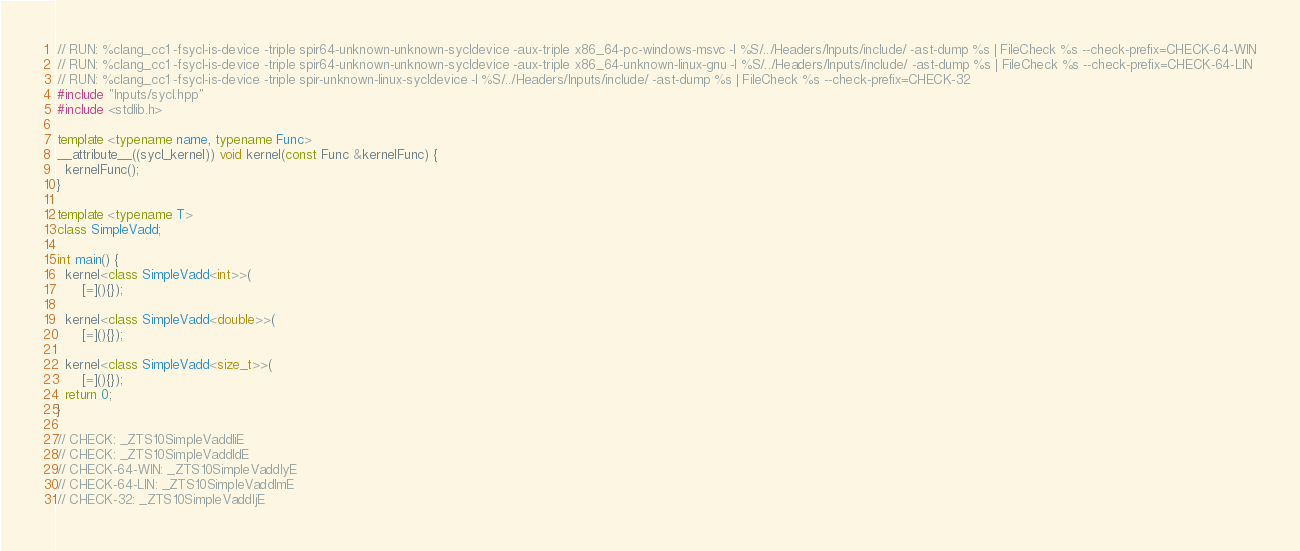<code> <loc_0><loc_0><loc_500><loc_500><_C++_>// RUN: %clang_cc1 -fsycl-is-device -triple spir64-unknown-unknown-sycldevice -aux-triple x86_64-pc-windows-msvc -I %S/../Headers/Inputs/include/ -ast-dump %s | FileCheck %s --check-prefix=CHECK-64-WIN
// RUN: %clang_cc1 -fsycl-is-device -triple spir64-unknown-unknown-sycldevice -aux-triple x86_64-unknown-linux-gnu -I %S/../Headers/Inputs/include/ -ast-dump %s | FileCheck %s --check-prefix=CHECK-64-LIN
// RUN: %clang_cc1 -fsycl-is-device -triple spir-unknown-linux-sycldevice -I %S/../Headers/Inputs/include/ -ast-dump %s | FileCheck %s --check-prefix=CHECK-32
#include "Inputs/sycl.hpp"
#include <stdlib.h>

template <typename name, typename Func>
__attribute__((sycl_kernel)) void kernel(const Func &kernelFunc) {
  kernelFunc();
}

template <typename T>
class SimpleVadd;

int main() {
  kernel<class SimpleVadd<int>>(
      [=](){});

  kernel<class SimpleVadd<double>>(
      [=](){});

  kernel<class SimpleVadd<size_t>>(
      [=](){});
  return 0;
}

// CHECK: _ZTS10SimpleVaddIiE
// CHECK: _ZTS10SimpleVaddIdE
// CHECK-64-WIN: _ZTS10SimpleVaddIyE
// CHECK-64-LIN: _ZTS10SimpleVaddImE
// CHECK-32: _ZTS10SimpleVaddIjE
</code> 